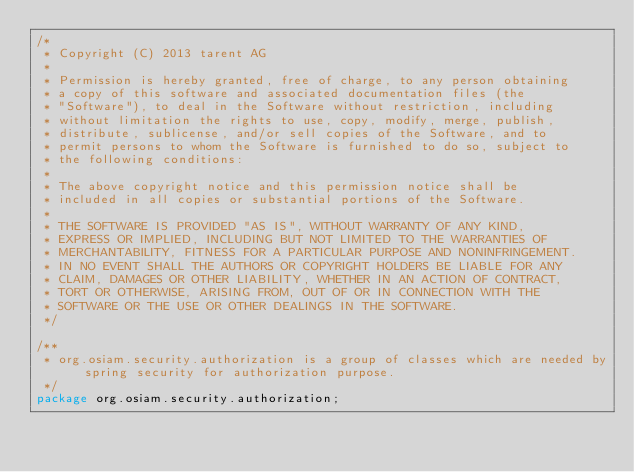Convert code to text. <code><loc_0><loc_0><loc_500><loc_500><_Java_>/*
 * Copyright (C) 2013 tarent AG
 *
 * Permission is hereby granted, free of charge, to any person obtaining
 * a copy of this software and associated documentation files (the
 * "Software"), to deal in the Software without restriction, including
 * without limitation the rights to use, copy, modify, merge, publish,
 * distribute, sublicense, and/or sell copies of the Software, and to
 * permit persons to whom the Software is furnished to do so, subject to
 * the following conditions:
 *
 * The above copyright notice and this permission notice shall be
 * included in all copies or substantial portions of the Software.
 *
 * THE SOFTWARE IS PROVIDED "AS IS", WITHOUT WARRANTY OF ANY KIND,
 * EXPRESS OR IMPLIED, INCLUDING BUT NOT LIMITED TO THE WARRANTIES OF
 * MERCHANTABILITY, FITNESS FOR A PARTICULAR PURPOSE AND NONINFRINGEMENT.
 * IN NO EVENT SHALL THE AUTHORS OR COPYRIGHT HOLDERS BE LIABLE FOR ANY
 * CLAIM, DAMAGES OR OTHER LIABILITY, WHETHER IN AN ACTION OF CONTRACT,
 * TORT OR OTHERWISE, ARISING FROM, OUT OF OR IN CONNECTION WITH THE
 * SOFTWARE OR THE USE OR OTHER DEALINGS IN THE SOFTWARE.
 */

/**
 * org.osiam.security.authorization is a group of classes which are needed by spring security for authorization purpose.
 */
package org.osiam.security.authorization;</code> 